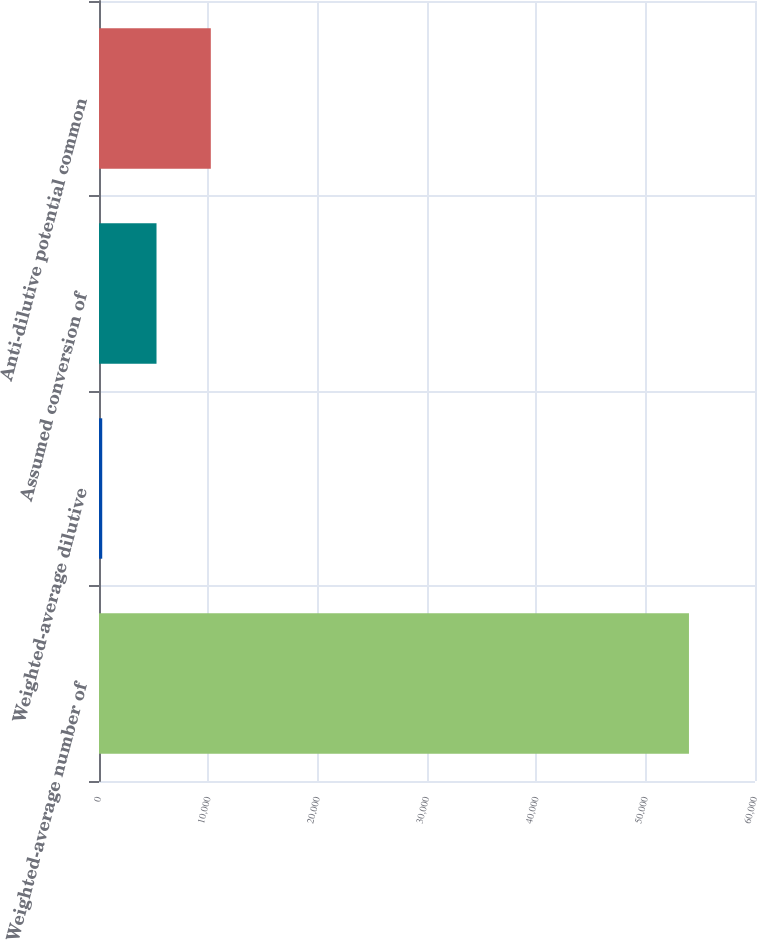Convert chart to OTSL. <chart><loc_0><loc_0><loc_500><loc_500><bar_chart><fcel>Weighted-average number of<fcel>Weighted-average dilutive<fcel>Assumed conversion of<fcel>Anti-dilutive potential common<nl><fcel>53959.9<fcel>295<fcel>5260.9<fcel>10226.8<nl></chart> 